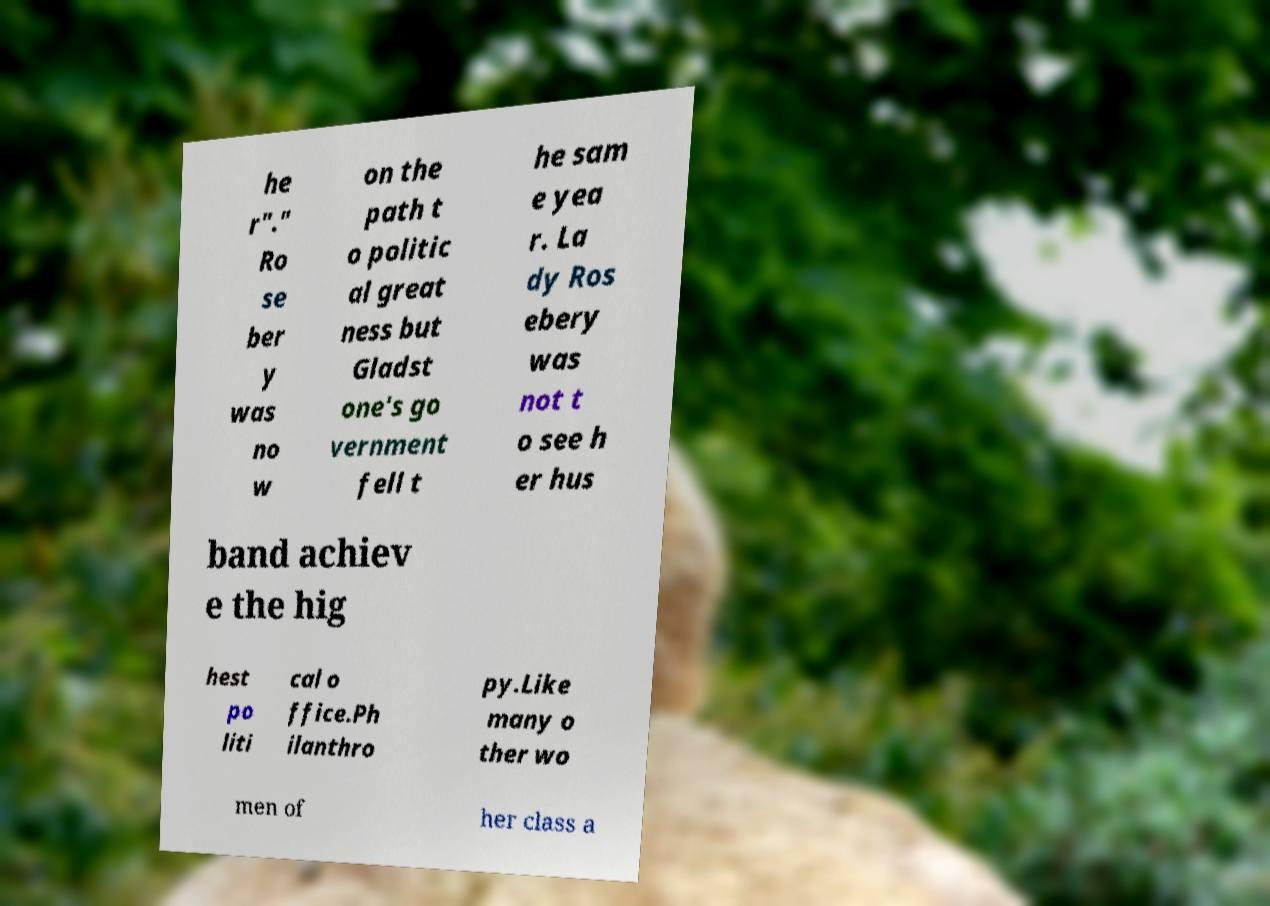There's text embedded in this image that I need extracted. Can you transcribe it verbatim? he r"." Ro se ber y was no w on the path t o politic al great ness but Gladst one's go vernment fell t he sam e yea r. La dy Ros ebery was not t o see h er hus band achiev e the hig hest po liti cal o ffice.Ph ilanthro py.Like many o ther wo men of her class a 